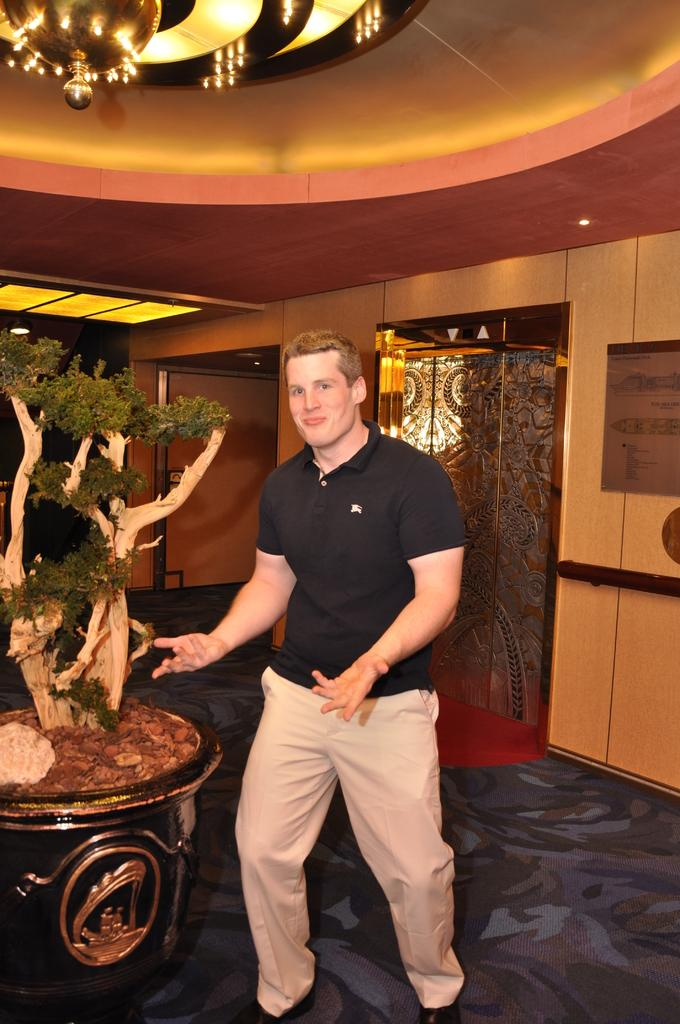What is the man in the image wearing? The man is wearing a black t-shirt and pants. Can you describe the plant in the image? There is a plant on the left side of the image. What type of lighting fixture is visible at the top of the image? There is a chandelier at the top of the image. What architectural feature can be seen at the back of the image? There is a door at the back of the image. How many hammers are hanging from the branches in the image? There are no hammers or branches present in the image. What type of snakes can be seen slithering on the floor in the image? There are no snakes present in the image. 